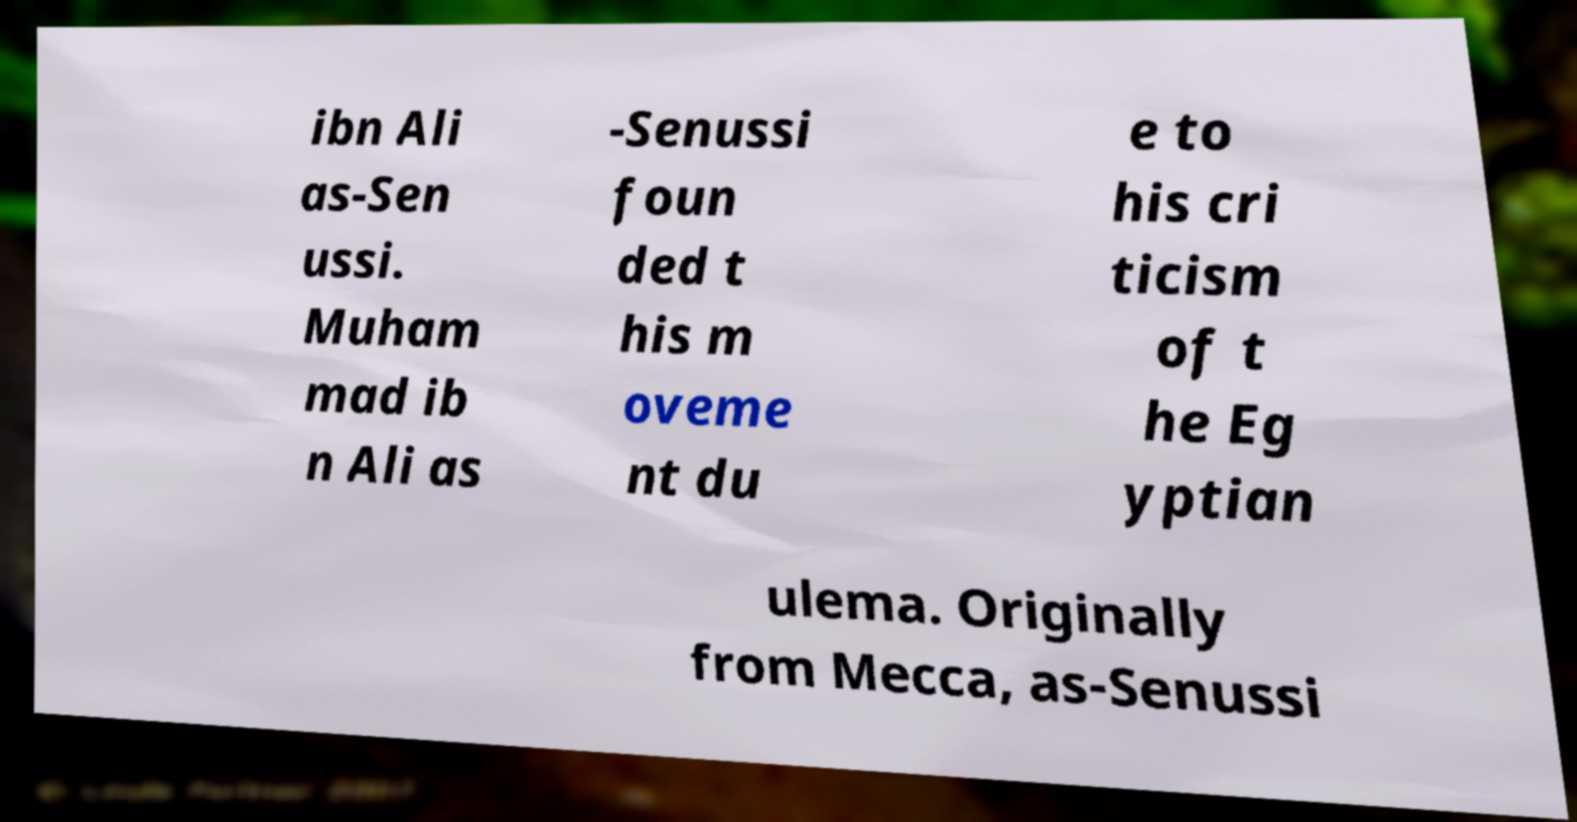Could you extract and type out the text from this image? ibn Ali as-Sen ussi. Muham mad ib n Ali as -Senussi foun ded t his m oveme nt du e to his cri ticism of t he Eg yptian ulema. Originally from Mecca, as-Senussi 